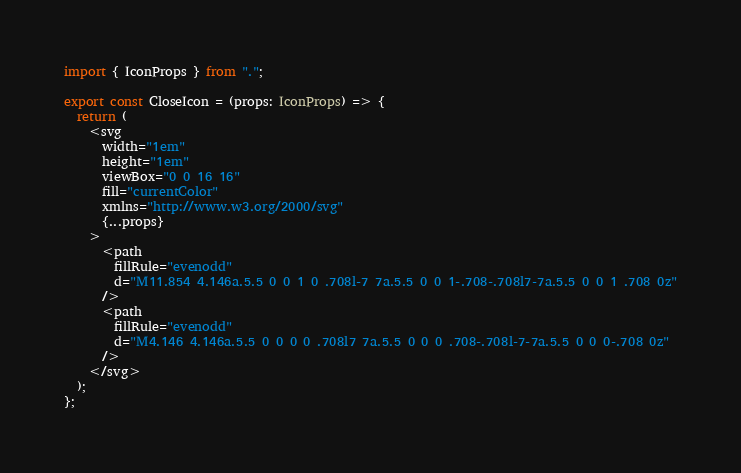<code> <loc_0><loc_0><loc_500><loc_500><_TypeScript_>import { IconProps } from ".";

export const CloseIcon = (props: IconProps) => {
  return (
    <svg
      width="1em"
      height="1em"
      viewBox="0 0 16 16"
      fill="currentColor"
      xmlns="http://www.w3.org/2000/svg"
      {...props}
    >
      <path
        fillRule="evenodd"
        d="M11.854 4.146a.5.5 0 0 1 0 .708l-7 7a.5.5 0 0 1-.708-.708l7-7a.5.5 0 0 1 .708 0z"
      />
      <path
        fillRule="evenodd"
        d="M4.146 4.146a.5.5 0 0 0 0 .708l7 7a.5.5 0 0 0 .708-.708l-7-7a.5.5 0 0 0-.708 0z"
      />
    </svg>
  );
};
</code> 